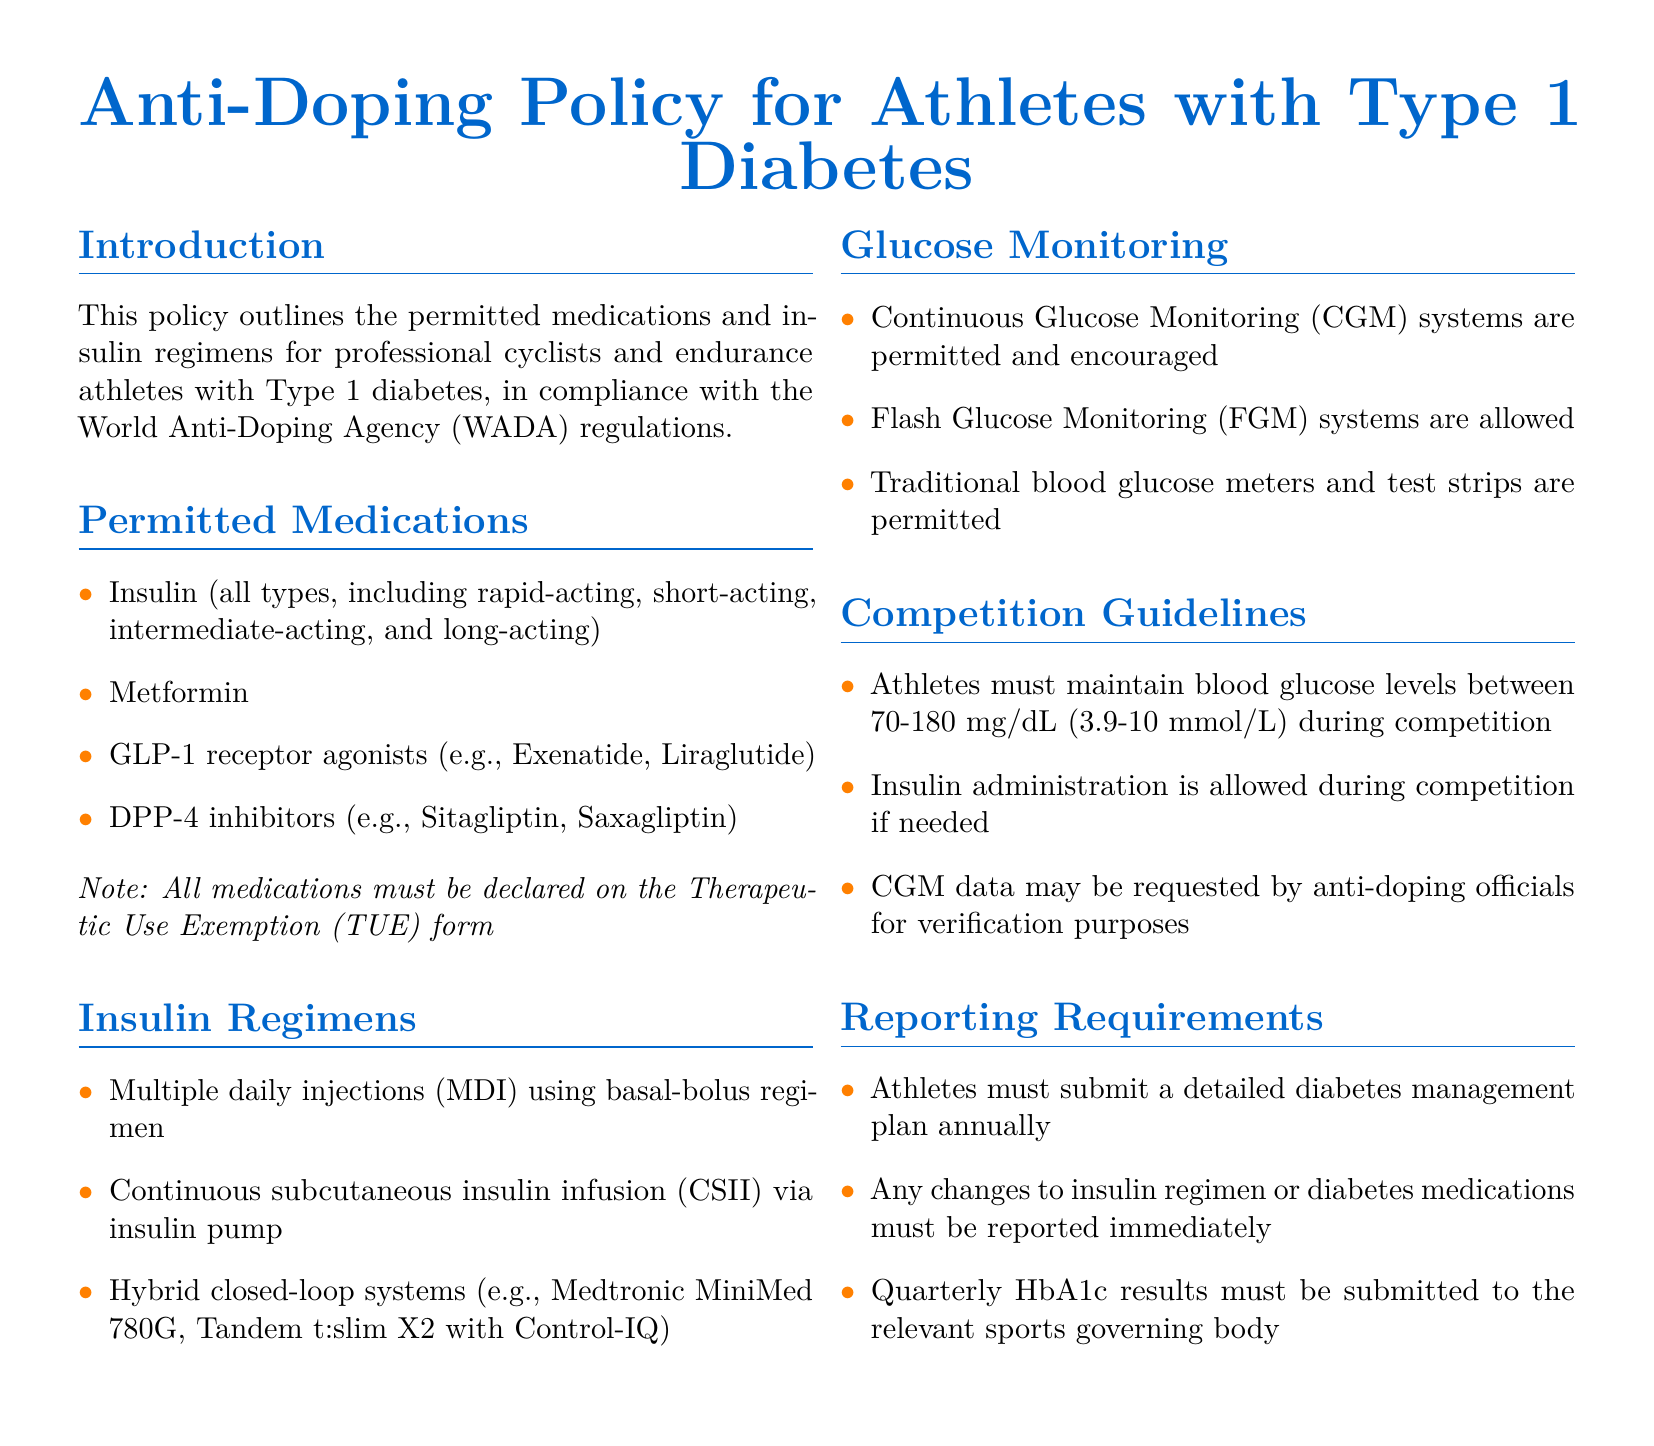What is the title of the policy document? The title provides an overview of the document's focus on anti-doping regulations for athletes with diabetes.
Answer: Anti-Doping Policy for Athletes with Type 1 Diabetes Which medications are permitted for athletes with Type 1 diabetes? The list includes various medications that athletes are allowed to use while complying with anti-doping regulations.
Answer: Insulin, Metformin, GLP-1 receptor agonists, DPP-4 inhibitors What is one allowed method for insulin administration during competition? The document outlines permitted insulin administration methods, emphasizing flexibility for athletes.
Answer: Insulin administration What glucose level range must athletes maintain during competitions? The range specifies the required blood glucose levels to ensure the safety and performance of athletes during events.
Answer: 70-180 mg/dL What must athletes submit annually regarding their diabetes management? This requirement ensures that athletes keep authorities informed of their medical needs and management plans.
Answer: Detailed diabetes management plan Which glucose monitoring system is encouraged for athletes? Continuous glucose monitoring is highlighted as a preferred method for tracking blood glucose levels effectively.
Answer: Continuous Glucose Monitoring (CGM) How often must HbA1c results be submitted? The frequency of HbA1c submissions is specified to maintain oversight of the athlete's diabetes management.
Answer: Quarterly What can anti-doping officials request from athletes? This request aids in verifying compliance with the regulations outlined in the document regarding diabetes management.
Answer: CGM data What type of insulin regimen is mentioned in the document? This regimen refers to a specific method of managing insulin delivery that is allowed for athletes.
Answer: Multiple daily injections (MDI) 